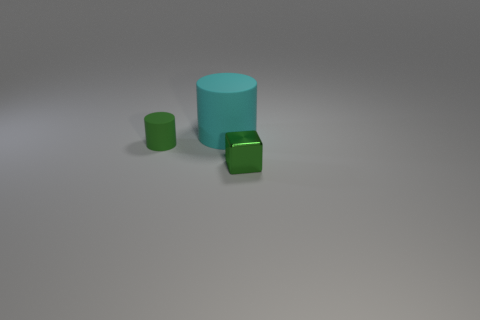Add 2 things. How many objects exist? 5 Subtract all cylinders. How many objects are left? 1 Add 1 cyan matte objects. How many cyan matte objects exist? 2 Subtract 1 cyan cylinders. How many objects are left? 2 Subtract all cyan objects. Subtract all blue metallic blocks. How many objects are left? 2 Add 3 green things. How many green things are left? 5 